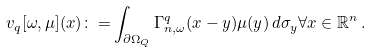<formula> <loc_0><loc_0><loc_500><loc_500>v _ { q } [ \omega , \mu ] ( x ) { \colon = } \int _ { \partial { \Omega _ { Q } } } \Gamma ^ { q } _ { n , \omega } ( x - y ) \mu ( y ) \, d \sigma _ { y } \forall x \in \mathbb { R } ^ { n } \, .</formula> 